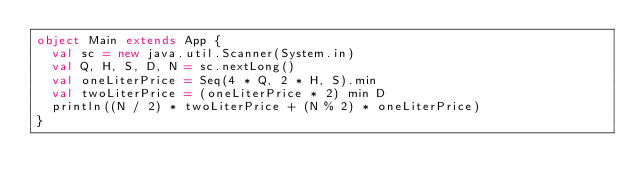Convert code to text. <code><loc_0><loc_0><loc_500><loc_500><_Scala_>object Main extends App {
  val sc = new java.util.Scanner(System.in)
  val Q, H, S, D, N = sc.nextLong()
  val oneLiterPrice = Seq(4 * Q, 2 * H, S).min
  val twoLiterPrice = (oneLiterPrice * 2) min D
  println((N / 2) * twoLiterPrice + (N % 2) * oneLiterPrice)
}
</code> 